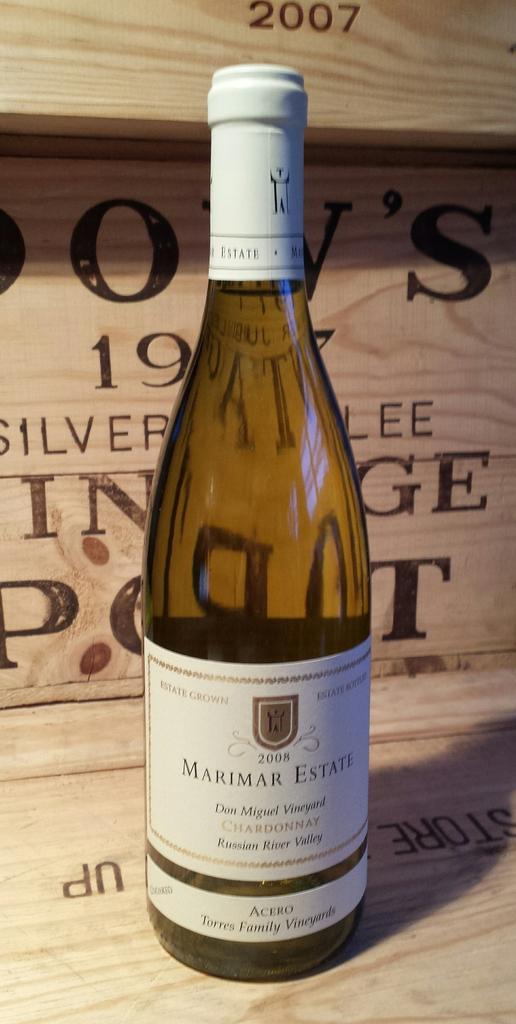What kind of wine is this?
Offer a terse response. Chardonnay. What number is behind the wine?
Keep it short and to the point. 19. 